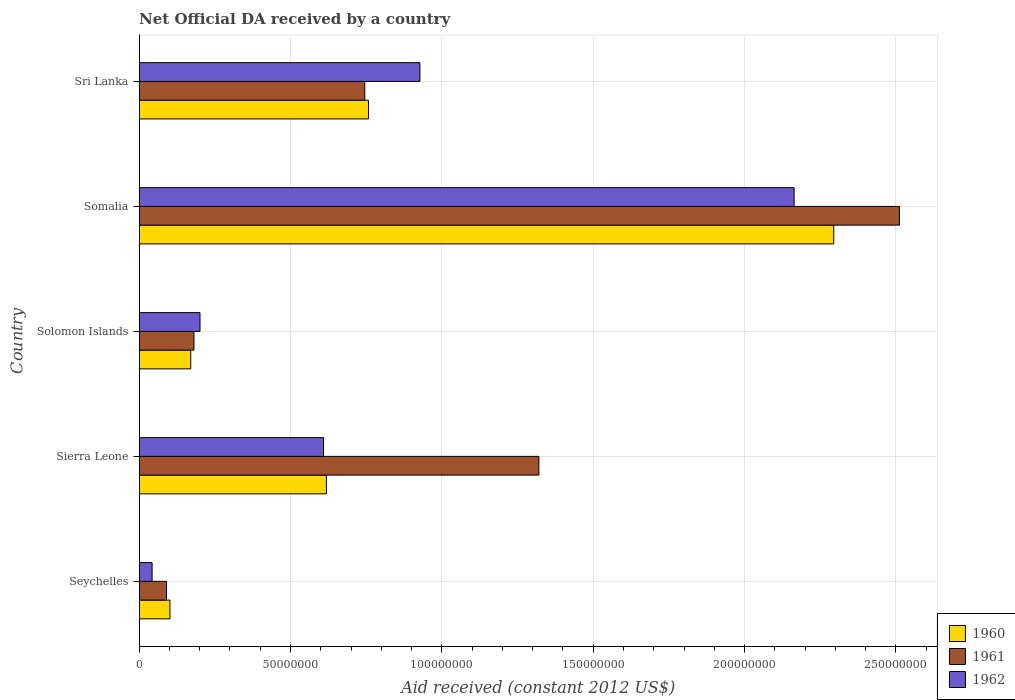How many different coloured bars are there?
Give a very brief answer. 3. How many groups of bars are there?
Provide a short and direct response. 5. How many bars are there on the 3rd tick from the top?
Your answer should be compact. 3. What is the label of the 4th group of bars from the top?
Provide a short and direct response. Sierra Leone. What is the net official development assistance aid received in 1962 in Seychelles?
Ensure brevity in your answer.  4.27e+06. Across all countries, what is the maximum net official development assistance aid received in 1961?
Ensure brevity in your answer.  2.51e+08. Across all countries, what is the minimum net official development assistance aid received in 1961?
Make the answer very short. 9.03e+06. In which country was the net official development assistance aid received in 1961 maximum?
Offer a very short reply. Somalia. In which country was the net official development assistance aid received in 1962 minimum?
Offer a very short reply. Seychelles. What is the total net official development assistance aid received in 1962 in the graph?
Your answer should be very brief. 3.94e+08. What is the difference between the net official development assistance aid received in 1960 in Sierra Leone and that in Somalia?
Your response must be concise. -1.68e+08. What is the difference between the net official development assistance aid received in 1961 in Solomon Islands and the net official development assistance aid received in 1960 in Seychelles?
Provide a short and direct response. 7.94e+06. What is the average net official development assistance aid received in 1960 per country?
Ensure brevity in your answer.  7.89e+07. What is the difference between the net official development assistance aid received in 1961 and net official development assistance aid received in 1960 in Seychelles?
Offer a very short reply. -1.14e+06. In how many countries, is the net official development assistance aid received in 1962 greater than 160000000 US$?
Keep it short and to the point. 1. What is the ratio of the net official development assistance aid received in 1960 in Solomon Islands to that in Somalia?
Your response must be concise. 0.07. Is the net official development assistance aid received in 1961 in Solomon Islands less than that in Somalia?
Your answer should be very brief. Yes. Is the difference between the net official development assistance aid received in 1961 in Seychelles and Solomon Islands greater than the difference between the net official development assistance aid received in 1960 in Seychelles and Solomon Islands?
Your answer should be very brief. No. What is the difference between the highest and the second highest net official development assistance aid received in 1960?
Ensure brevity in your answer.  1.54e+08. What is the difference between the highest and the lowest net official development assistance aid received in 1960?
Give a very brief answer. 2.19e+08. In how many countries, is the net official development assistance aid received in 1960 greater than the average net official development assistance aid received in 1960 taken over all countries?
Provide a short and direct response. 1. Is the sum of the net official development assistance aid received in 1962 in Solomon Islands and Sri Lanka greater than the maximum net official development assistance aid received in 1960 across all countries?
Provide a succinct answer. No. What does the 1st bar from the top in Sri Lanka represents?
Your answer should be very brief. 1962. Is it the case that in every country, the sum of the net official development assistance aid received in 1961 and net official development assistance aid received in 1960 is greater than the net official development assistance aid received in 1962?
Your answer should be very brief. Yes. How many countries are there in the graph?
Your response must be concise. 5. What is the difference between two consecutive major ticks on the X-axis?
Your answer should be compact. 5.00e+07. Does the graph contain grids?
Keep it short and to the point. Yes. Where does the legend appear in the graph?
Give a very brief answer. Bottom right. How many legend labels are there?
Provide a short and direct response. 3. How are the legend labels stacked?
Your response must be concise. Vertical. What is the title of the graph?
Your answer should be very brief. Net Official DA received by a country. What is the label or title of the X-axis?
Provide a short and direct response. Aid received (constant 2012 US$). What is the label or title of the Y-axis?
Your answer should be compact. Country. What is the Aid received (constant 2012 US$) in 1960 in Seychelles?
Offer a terse response. 1.02e+07. What is the Aid received (constant 2012 US$) in 1961 in Seychelles?
Provide a succinct answer. 9.03e+06. What is the Aid received (constant 2012 US$) in 1962 in Seychelles?
Keep it short and to the point. 4.27e+06. What is the Aid received (constant 2012 US$) of 1960 in Sierra Leone?
Ensure brevity in your answer.  6.18e+07. What is the Aid received (constant 2012 US$) of 1961 in Sierra Leone?
Make the answer very short. 1.32e+08. What is the Aid received (constant 2012 US$) of 1962 in Sierra Leone?
Offer a terse response. 6.09e+07. What is the Aid received (constant 2012 US$) of 1960 in Solomon Islands?
Your answer should be compact. 1.70e+07. What is the Aid received (constant 2012 US$) of 1961 in Solomon Islands?
Offer a very short reply. 1.81e+07. What is the Aid received (constant 2012 US$) of 1962 in Solomon Islands?
Offer a very short reply. 2.01e+07. What is the Aid received (constant 2012 US$) in 1960 in Somalia?
Provide a succinct answer. 2.29e+08. What is the Aid received (constant 2012 US$) in 1961 in Somalia?
Your answer should be very brief. 2.51e+08. What is the Aid received (constant 2012 US$) in 1962 in Somalia?
Provide a succinct answer. 2.16e+08. What is the Aid received (constant 2012 US$) in 1960 in Sri Lanka?
Keep it short and to the point. 7.58e+07. What is the Aid received (constant 2012 US$) in 1961 in Sri Lanka?
Your response must be concise. 7.45e+07. What is the Aid received (constant 2012 US$) of 1962 in Sri Lanka?
Give a very brief answer. 9.28e+07. Across all countries, what is the maximum Aid received (constant 2012 US$) of 1960?
Offer a terse response. 2.29e+08. Across all countries, what is the maximum Aid received (constant 2012 US$) of 1961?
Your answer should be very brief. 2.51e+08. Across all countries, what is the maximum Aid received (constant 2012 US$) of 1962?
Your answer should be very brief. 2.16e+08. Across all countries, what is the minimum Aid received (constant 2012 US$) in 1960?
Offer a very short reply. 1.02e+07. Across all countries, what is the minimum Aid received (constant 2012 US$) in 1961?
Make the answer very short. 9.03e+06. Across all countries, what is the minimum Aid received (constant 2012 US$) in 1962?
Your answer should be compact. 4.27e+06. What is the total Aid received (constant 2012 US$) of 1960 in the graph?
Offer a very short reply. 3.94e+08. What is the total Aid received (constant 2012 US$) of 1961 in the graph?
Provide a succinct answer. 4.85e+08. What is the total Aid received (constant 2012 US$) of 1962 in the graph?
Keep it short and to the point. 3.94e+08. What is the difference between the Aid received (constant 2012 US$) in 1960 in Seychelles and that in Sierra Leone?
Give a very brief answer. -5.17e+07. What is the difference between the Aid received (constant 2012 US$) in 1961 in Seychelles and that in Sierra Leone?
Provide a succinct answer. -1.23e+08. What is the difference between the Aid received (constant 2012 US$) in 1962 in Seychelles and that in Sierra Leone?
Provide a short and direct response. -5.66e+07. What is the difference between the Aid received (constant 2012 US$) of 1960 in Seychelles and that in Solomon Islands?
Your response must be concise. -6.87e+06. What is the difference between the Aid received (constant 2012 US$) in 1961 in Seychelles and that in Solomon Islands?
Provide a short and direct response. -9.08e+06. What is the difference between the Aid received (constant 2012 US$) in 1962 in Seychelles and that in Solomon Islands?
Ensure brevity in your answer.  -1.58e+07. What is the difference between the Aid received (constant 2012 US$) in 1960 in Seychelles and that in Somalia?
Offer a very short reply. -2.19e+08. What is the difference between the Aid received (constant 2012 US$) of 1961 in Seychelles and that in Somalia?
Offer a very short reply. -2.42e+08. What is the difference between the Aid received (constant 2012 US$) in 1962 in Seychelles and that in Somalia?
Offer a very short reply. -2.12e+08. What is the difference between the Aid received (constant 2012 US$) in 1960 in Seychelles and that in Sri Lanka?
Provide a succinct answer. -6.56e+07. What is the difference between the Aid received (constant 2012 US$) in 1961 in Seychelles and that in Sri Lanka?
Offer a very short reply. -6.55e+07. What is the difference between the Aid received (constant 2012 US$) in 1962 in Seychelles and that in Sri Lanka?
Your response must be concise. -8.85e+07. What is the difference between the Aid received (constant 2012 US$) of 1960 in Sierra Leone and that in Solomon Islands?
Keep it short and to the point. 4.48e+07. What is the difference between the Aid received (constant 2012 US$) of 1961 in Sierra Leone and that in Solomon Islands?
Give a very brief answer. 1.14e+08. What is the difference between the Aid received (constant 2012 US$) in 1962 in Sierra Leone and that in Solomon Islands?
Offer a very short reply. 4.08e+07. What is the difference between the Aid received (constant 2012 US$) of 1960 in Sierra Leone and that in Somalia?
Give a very brief answer. -1.68e+08. What is the difference between the Aid received (constant 2012 US$) of 1961 in Sierra Leone and that in Somalia?
Your answer should be very brief. -1.19e+08. What is the difference between the Aid received (constant 2012 US$) of 1962 in Sierra Leone and that in Somalia?
Provide a succinct answer. -1.55e+08. What is the difference between the Aid received (constant 2012 US$) of 1960 in Sierra Leone and that in Sri Lanka?
Your answer should be very brief. -1.39e+07. What is the difference between the Aid received (constant 2012 US$) of 1961 in Sierra Leone and that in Sri Lanka?
Your response must be concise. 5.75e+07. What is the difference between the Aid received (constant 2012 US$) of 1962 in Sierra Leone and that in Sri Lanka?
Ensure brevity in your answer.  -3.18e+07. What is the difference between the Aid received (constant 2012 US$) in 1960 in Solomon Islands and that in Somalia?
Offer a very short reply. -2.12e+08. What is the difference between the Aid received (constant 2012 US$) of 1961 in Solomon Islands and that in Somalia?
Offer a very short reply. -2.33e+08. What is the difference between the Aid received (constant 2012 US$) of 1962 in Solomon Islands and that in Somalia?
Keep it short and to the point. -1.96e+08. What is the difference between the Aid received (constant 2012 US$) of 1960 in Solomon Islands and that in Sri Lanka?
Offer a very short reply. -5.87e+07. What is the difference between the Aid received (constant 2012 US$) of 1961 in Solomon Islands and that in Sri Lanka?
Make the answer very short. -5.64e+07. What is the difference between the Aid received (constant 2012 US$) in 1962 in Solomon Islands and that in Sri Lanka?
Ensure brevity in your answer.  -7.26e+07. What is the difference between the Aid received (constant 2012 US$) of 1960 in Somalia and that in Sri Lanka?
Offer a terse response. 1.54e+08. What is the difference between the Aid received (constant 2012 US$) in 1961 in Somalia and that in Sri Lanka?
Keep it short and to the point. 1.77e+08. What is the difference between the Aid received (constant 2012 US$) in 1962 in Somalia and that in Sri Lanka?
Your answer should be very brief. 1.24e+08. What is the difference between the Aid received (constant 2012 US$) in 1960 in Seychelles and the Aid received (constant 2012 US$) in 1961 in Sierra Leone?
Your answer should be very brief. -1.22e+08. What is the difference between the Aid received (constant 2012 US$) in 1960 in Seychelles and the Aid received (constant 2012 US$) in 1962 in Sierra Leone?
Keep it short and to the point. -5.07e+07. What is the difference between the Aid received (constant 2012 US$) in 1961 in Seychelles and the Aid received (constant 2012 US$) in 1962 in Sierra Leone?
Offer a very short reply. -5.19e+07. What is the difference between the Aid received (constant 2012 US$) in 1960 in Seychelles and the Aid received (constant 2012 US$) in 1961 in Solomon Islands?
Keep it short and to the point. -7.94e+06. What is the difference between the Aid received (constant 2012 US$) in 1960 in Seychelles and the Aid received (constant 2012 US$) in 1962 in Solomon Islands?
Give a very brief answer. -9.93e+06. What is the difference between the Aid received (constant 2012 US$) of 1961 in Seychelles and the Aid received (constant 2012 US$) of 1962 in Solomon Islands?
Keep it short and to the point. -1.11e+07. What is the difference between the Aid received (constant 2012 US$) in 1960 in Seychelles and the Aid received (constant 2012 US$) in 1961 in Somalia?
Provide a short and direct response. -2.41e+08. What is the difference between the Aid received (constant 2012 US$) in 1960 in Seychelles and the Aid received (constant 2012 US$) in 1962 in Somalia?
Make the answer very short. -2.06e+08. What is the difference between the Aid received (constant 2012 US$) of 1961 in Seychelles and the Aid received (constant 2012 US$) of 1962 in Somalia?
Offer a very short reply. -2.07e+08. What is the difference between the Aid received (constant 2012 US$) in 1960 in Seychelles and the Aid received (constant 2012 US$) in 1961 in Sri Lanka?
Give a very brief answer. -6.44e+07. What is the difference between the Aid received (constant 2012 US$) in 1960 in Seychelles and the Aid received (constant 2012 US$) in 1962 in Sri Lanka?
Give a very brief answer. -8.26e+07. What is the difference between the Aid received (constant 2012 US$) in 1961 in Seychelles and the Aid received (constant 2012 US$) in 1962 in Sri Lanka?
Provide a succinct answer. -8.37e+07. What is the difference between the Aid received (constant 2012 US$) in 1960 in Sierra Leone and the Aid received (constant 2012 US$) in 1961 in Solomon Islands?
Provide a succinct answer. 4.37e+07. What is the difference between the Aid received (constant 2012 US$) of 1960 in Sierra Leone and the Aid received (constant 2012 US$) of 1962 in Solomon Islands?
Give a very brief answer. 4.18e+07. What is the difference between the Aid received (constant 2012 US$) in 1961 in Sierra Leone and the Aid received (constant 2012 US$) in 1962 in Solomon Islands?
Provide a short and direct response. 1.12e+08. What is the difference between the Aid received (constant 2012 US$) of 1960 in Sierra Leone and the Aid received (constant 2012 US$) of 1961 in Somalia?
Provide a short and direct response. -1.89e+08. What is the difference between the Aid received (constant 2012 US$) of 1960 in Sierra Leone and the Aid received (constant 2012 US$) of 1962 in Somalia?
Your response must be concise. -1.55e+08. What is the difference between the Aid received (constant 2012 US$) of 1961 in Sierra Leone and the Aid received (constant 2012 US$) of 1962 in Somalia?
Ensure brevity in your answer.  -8.43e+07. What is the difference between the Aid received (constant 2012 US$) in 1960 in Sierra Leone and the Aid received (constant 2012 US$) in 1961 in Sri Lanka?
Offer a terse response. -1.27e+07. What is the difference between the Aid received (constant 2012 US$) of 1960 in Sierra Leone and the Aid received (constant 2012 US$) of 1962 in Sri Lanka?
Your answer should be compact. -3.09e+07. What is the difference between the Aid received (constant 2012 US$) in 1961 in Sierra Leone and the Aid received (constant 2012 US$) in 1962 in Sri Lanka?
Offer a very short reply. 3.93e+07. What is the difference between the Aid received (constant 2012 US$) of 1960 in Solomon Islands and the Aid received (constant 2012 US$) of 1961 in Somalia?
Your answer should be compact. -2.34e+08. What is the difference between the Aid received (constant 2012 US$) of 1960 in Solomon Islands and the Aid received (constant 2012 US$) of 1962 in Somalia?
Offer a terse response. -1.99e+08. What is the difference between the Aid received (constant 2012 US$) in 1961 in Solomon Islands and the Aid received (constant 2012 US$) in 1962 in Somalia?
Provide a succinct answer. -1.98e+08. What is the difference between the Aid received (constant 2012 US$) of 1960 in Solomon Islands and the Aid received (constant 2012 US$) of 1961 in Sri Lanka?
Make the answer very short. -5.75e+07. What is the difference between the Aid received (constant 2012 US$) in 1960 in Solomon Islands and the Aid received (constant 2012 US$) in 1962 in Sri Lanka?
Give a very brief answer. -7.57e+07. What is the difference between the Aid received (constant 2012 US$) of 1961 in Solomon Islands and the Aid received (constant 2012 US$) of 1962 in Sri Lanka?
Provide a succinct answer. -7.46e+07. What is the difference between the Aid received (constant 2012 US$) in 1960 in Somalia and the Aid received (constant 2012 US$) in 1961 in Sri Lanka?
Make the answer very short. 1.55e+08. What is the difference between the Aid received (constant 2012 US$) in 1960 in Somalia and the Aid received (constant 2012 US$) in 1962 in Sri Lanka?
Your response must be concise. 1.37e+08. What is the difference between the Aid received (constant 2012 US$) of 1961 in Somalia and the Aid received (constant 2012 US$) of 1962 in Sri Lanka?
Your answer should be compact. 1.58e+08. What is the average Aid received (constant 2012 US$) in 1960 per country?
Provide a succinct answer. 7.89e+07. What is the average Aid received (constant 2012 US$) of 1961 per country?
Provide a succinct answer. 9.70e+07. What is the average Aid received (constant 2012 US$) in 1962 per country?
Make the answer very short. 7.89e+07. What is the difference between the Aid received (constant 2012 US$) in 1960 and Aid received (constant 2012 US$) in 1961 in Seychelles?
Ensure brevity in your answer.  1.14e+06. What is the difference between the Aid received (constant 2012 US$) in 1960 and Aid received (constant 2012 US$) in 1962 in Seychelles?
Your answer should be compact. 5.90e+06. What is the difference between the Aid received (constant 2012 US$) of 1961 and Aid received (constant 2012 US$) of 1962 in Seychelles?
Provide a short and direct response. 4.76e+06. What is the difference between the Aid received (constant 2012 US$) in 1960 and Aid received (constant 2012 US$) in 1961 in Sierra Leone?
Keep it short and to the point. -7.02e+07. What is the difference between the Aid received (constant 2012 US$) in 1960 and Aid received (constant 2012 US$) in 1962 in Sierra Leone?
Provide a short and direct response. 9.40e+05. What is the difference between the Aid received (constant 2012 US$) of 1961 and Aid received (constant 2012 US$) of 1962 in Sierra Leone?
Provide a short and direct response. 7.11e+07. What is the difference between the Aid received (constant 2012 US$) in 1960 and Aid received (constant 2012 US$) in 1961 in Solomon Islands?
Your answer should be compact. -1.07e+06. What is the difference between the Aid received (constant 2012 US$) of 1960 and Aid received (constant 2012 US$) of 1962 in Solomon Islands?
Provide a succinct answer. -3.06e+06. What is the difference between the Aid received (constant 2012 US$) of 1961 and Aid received (constant 2012 US$) of 1962 in Solomon Islands?
Provide a succinct answer. -1.99e+06. What is the difference between the Aid received (constant 2012 US$) of 1960 and Aid received (constant 2012 US$) of 1961 in Somalia?
Offer a very short reply. -2.17e+07. What is the difference between the Aid received (constant 2012 US$) of 1960 and Aid received (constant 2012 US$) of 1962 in Somalia?
Make the answer very short. 1.31e+07. What is the difference between the Aid received (constant 2012 US$) of 1961 and Aid received (constant 2012 US$) of 1962 in Somalia?
Offer a terse response. 3.48e+07. What is the difference between the Aid received (constant 2012 US$) in 1960 and Aid received (constant 2012 US$) in 1961 in Sri Lanka?
Give a very brief answer. 1.24e+06. What is the difference between the Aid received (constant 2012 US$) in 1960 and Aid received (constant 2012 US$) in 1962 in Sri Lanka?
Your answer should be compact. -1.70e+07. What is the difference between the Aid received (constant 2012 US$) in 1961 and Aid received (constant 2012 US$) in 1962 in Sri Lanka?
Keep it short and to the point. -1.82e+07. What is the ratio of the Aid received (constant 2012 US$) of 1960 in Seychelles to that in Sierra Leone?
Give a very brief answer. 0.16. What is the ratio of the Aid received (constant 2012 US$) of 1961 in Seychelles to that in Sierra Leone?
Make the answer very short. 0.07. What is the ratio of the Aid received (constant 2012 US$) in 1962 in Seychelles to that in Sierra Leone?
Provide a succinct answer. 0.07. What is the ratio of the Aid received (constant 2012 US$) in 1960 in Seychelles to that in Solomon Islands?
Offer a very short reply. 0.6. What is the ratio of the Aid received (constant 2012 US$) in 1961 in Seychelles to that in Solomon Islands?
Give a very brief answer. 0.5. What is the ratio of the Aid received (constant 2012 US$) in 1962 in Seychelles to that in Solomon Islands?
Your answer should be very brief. 0.21. What is the ratio of the Aid received (constant 2012 US$) of 1960 in Seychelles to that in Somalia?
Offer a terse response. 0.04. What is the ratio of the Aid received (constant 2012 US$) in 1961 in Seychelles to that in Somalia?
Keep it short and to the point. 0.04. What is the ratio of the Aid received (constant 2012 US$) of 1962 in Seychelles to that in Somalia?
Provide a succinct answer. 0.02. What is the ratio of the Aid received (constant 2012 US$) of 1960 in Seychelles to that in Sri Lanka?
Ensure brevity in your answer.  0.13. What is the ratio of the Aid received (constant 2012 US$) of 1961 in Seychelles to that in Sri Lanka?
Keep it short and to the point. 0.12. What is the ratio of the Aid received (constant 2012 US$) of 1962 in Seychelles to that in Sri Lanka?
Make the answer very short. 0.05. What is the ratio of the Aid received (constant 2012 US$) of 1960 in Sierra Leone to that in Solomon Islands?
Offer a terse response. 3.63. What is the ratio of the Aid received (constant 2012 US$) of 1961 in Sierra Leone to that in Solomon Islands?
Your answer should be very brief. 7.29. What is the ratio of the Aid received (constant 2012 US$) in 1962 in Sierra Leone to that in Solomon Islands?
Your response must be concise. 3.03. What is the ratio of the Aid received (constant 2012 US$) in 1960 in Sierra Leone to that in Somalia?
Your answer should be compact. 0.27. What is the ratio of the Aid received (constant 2012 US$) in 1961 in Sierra Leone to that in Somalia?
Ensure brevity in your answer.  0.53. What is the ratio of the Aid received (constant 2012 US$) in 1962 in Sierra Leone to that in Somalia?
Keep it short and to the point. 0.28. What is the ratio of the Aid received (constant 2012 US$) in 1960 in Sierra Leone to that in Sri Lanka?
Ensure brevity in your answer.  0.82. What is the ratio of the Aid received (constant 2012 US$) of 1961 in Sierra Leone to that in Sri Lanka?
Offer a very short reply. 1.77. What is the ratio of the Aid received (constant 2012 US$) in 1962 in Sierra Leone to that in Sri Lanka?
Your answer should be very brief. 0.66. What is the ratio of the Aid received (constant 2012 US$) of 1960 in Solomon Islands to that in Somalia?
Your answer should be compact. 0.07. What is the ratio of the Aid received (constant 2012 US$) in 1961 in Solomon Islands to that in Somalia?
Keep it short and to the point. 0.07. What is the ratio of the Aid received (constant 2012 US$) of 1962 in Solomon Islands to that in Somalia?
Your response must be concise. 0.09. What is the ratio of the Aid received (constant 2012 US$) of 1960 in Solomon Islands to that in Sri Lanka?
Offer a terse response. 0.22. What is the ratio of the Aid received (constant 2012 US$) in 1961 in Solomon Islands to that in Sri Lanka?
Provide a short and direct response. 0.24. What is the ratio of the Aid received (constant 2012 US$) in 1962 in Solomon Islands to that in Sri Lanka?
Your answer should be very brief. 0.22. What is the ratio of the Aid received (constant 2012 US$) of 1960 in Somalia to that in Sri Lanka?
Your answer should be very brief. 3.03. What is the ratio of the Aid received (constant 2012 US$) in 1961 in Somalia to that in Sri Lanka?
Provide a short and direct response. 3.37. What is the ratio of the Aid received (constant 2012 US$) of 1962 in Somalia to that in Sri Lanka?
Provide a short and direct response. 2.33. What is the difference between the highest and the second highest Aid received (constant 2012 US$) in 1960?
Provide a short and direct response. 1.54e+08. What is the difference between the highest and the second highest Aid received (constant 2012 US$) of 1961?
Provide a short and direct response. 1.19e+08. What is the difference between the highest and the second highest Aid received (constant 2012 US$) of 1962?
Offer a very short reply. 1.24e+08. What is the difference between the highest and the lowest Aid received (constant 2012 US$) of 1960?
Your answer should be very brief. 2.19e+08. What is the difference between the highest and the lowest Aid received (constant 2012 US$) in 1961?
Your answer should be compact. 2.42e+08. What is the difference between the highest and the lowest Aid received (constant 2012 US$) in 1962?
Your response must be concise. 2.12e+08. 